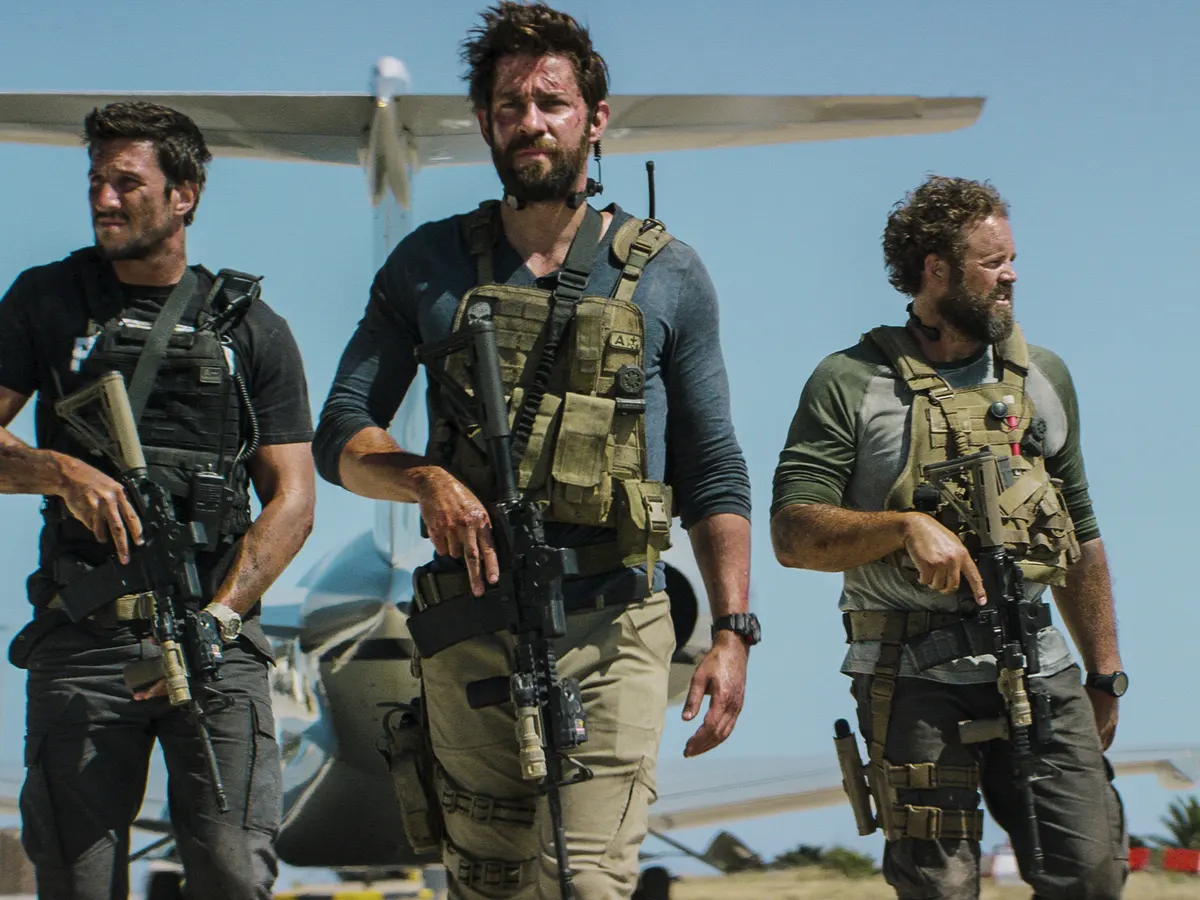Explain the visual content of the image in great detail. The image portrays three men dressed in tactical gear moving determinedly across an airstrip. The central figure has intense focus, suggesting a leadership role or critical moment in the action depicted. Each man is equipped with a rifle, adding to the urgency of the scene. Their gear includes beige vests, holsters, and various packs, indicating readiness for a substantial operation. Behind them, a small airplane is parked, hinting that their mission might involve air transport. The clear blue sky and the barren landscape surrounding the airstrip suggest a remote or isolated setting, potentially a military operation zone. 